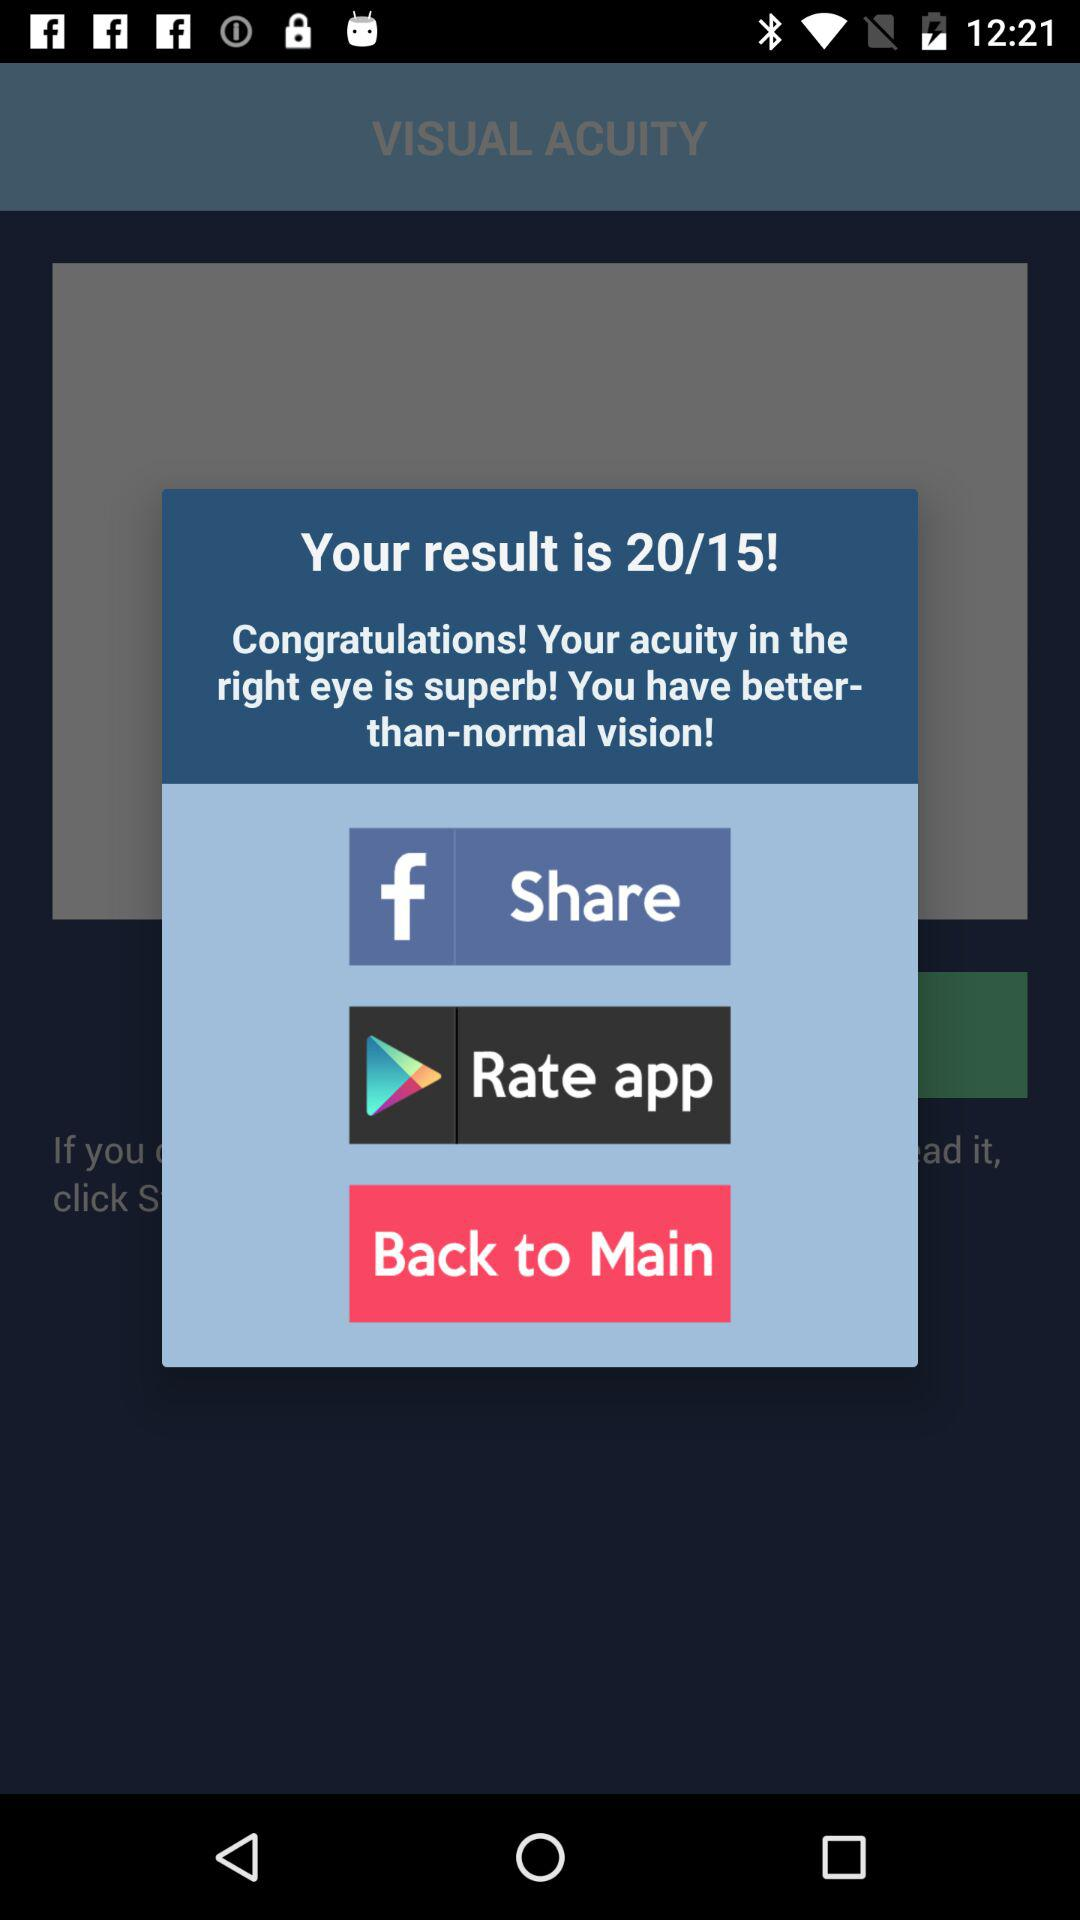What is the score out of 20? The score is 15. 